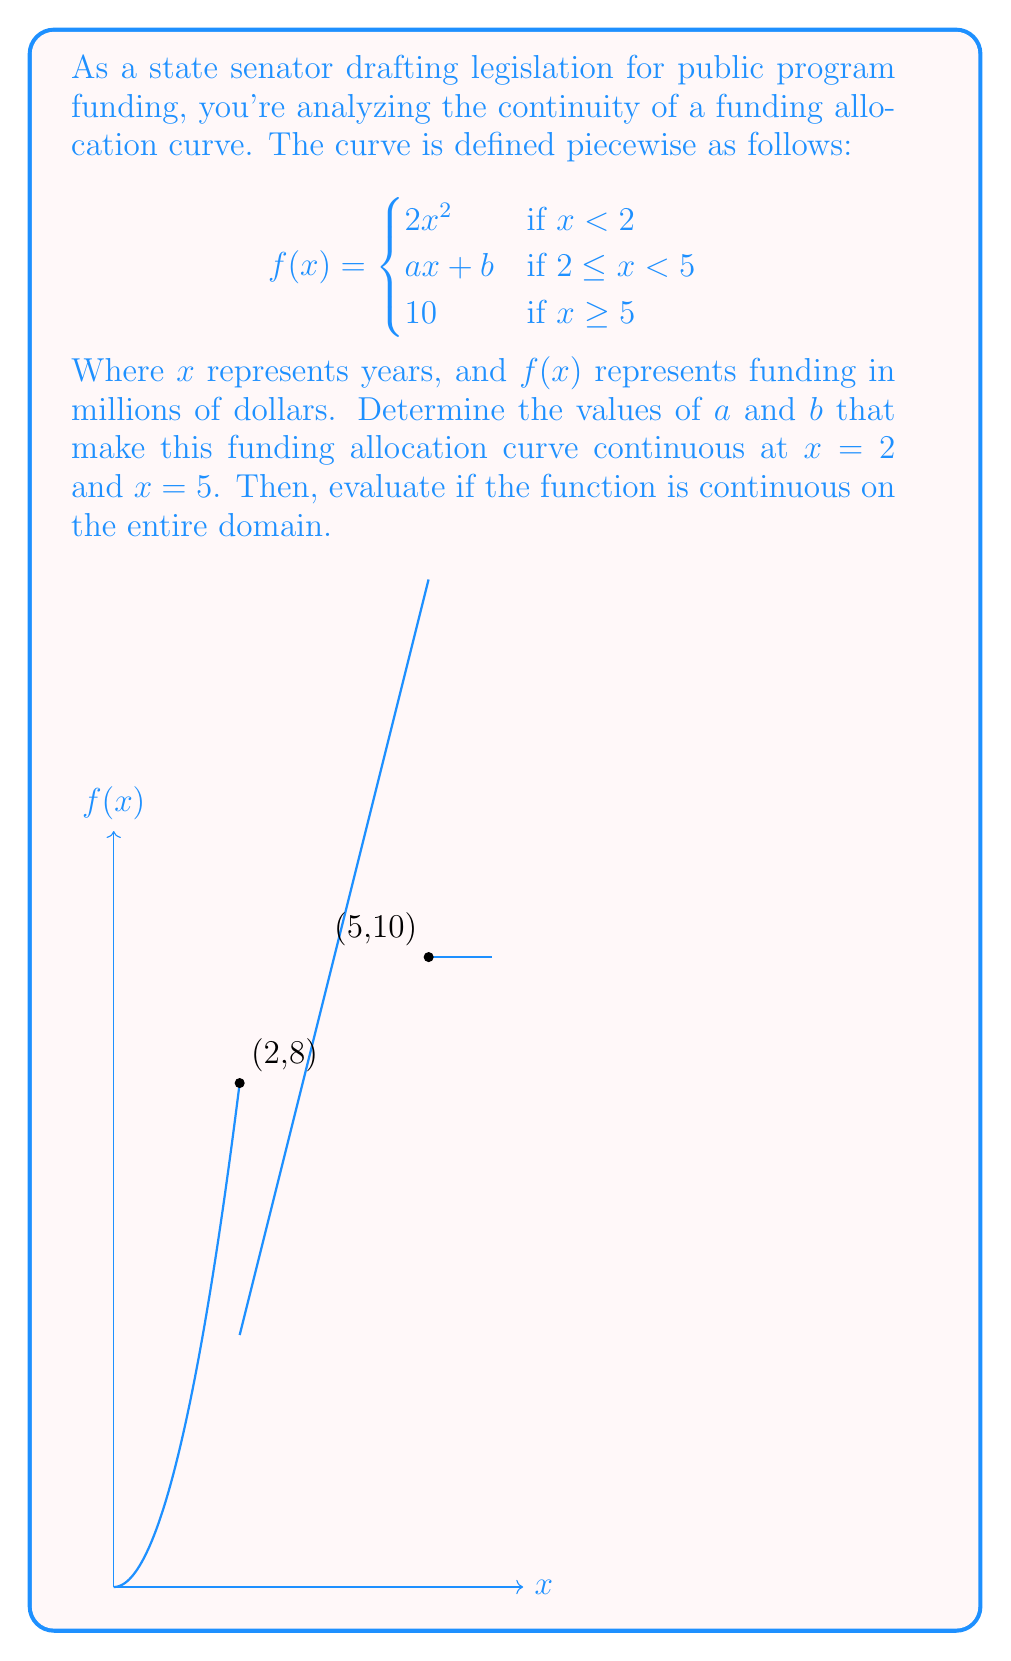Provide a solution to this math problem. To determine the values of $a$ and $b$ and evaluate the continuity:

1) For continuity at $x = 2$:
   The left-hand limit: $\lim_{x \to 2^-} 2x^2 = 2(2)^2 = 8$
   The right-hand limit: $\lim_{x \to 2^+} (ax + b) = 2a + b$
   For continuity: $8 = 2a + b$ (Equation 1)

2) For continuity at $x = 5$:
   The left-hand limit: $\lim_{x \to 5^-} (ax + b) = 5a + b$
   The right-hand limit: $\lim_{x \to 5^+} 10 = 10$
   For continuity: $5a + b = 10$ (Equation 2)

3) Solve the system of equations:
   Equation 1: $8 = 2a + b$
   Equation 2: $10 = 5a + b$
   
   Subtracting Equation 1 from Equation 2:
   $2 = 3a$
   $a = \frac{2}{3}$
   
   Substituting $a$ into Equation 1:
   $8 = 2(\frac{2}{3}) + b$
   $8 = \frac{4}{3} + b$
   $b = 8 - \frac{4}{3} = \frac{20}{3}$

4) Check continuity on the entire domain:
   - The function is continuous for $x < 2$ (polynomial function)
   - The function is continuous for $2 \leq x < 5$ (linear function)
   - The function is continuous for $x \geq 5$ (constant function)
   - We've ensured continuity at $x = 2$ and $x = 5$

Therefore, the function is continuous on the entire domain.
Answer: $a = \frac{2}{3}$, $b = \frac{20}{3}$; The function is continuous on the entire domain. 